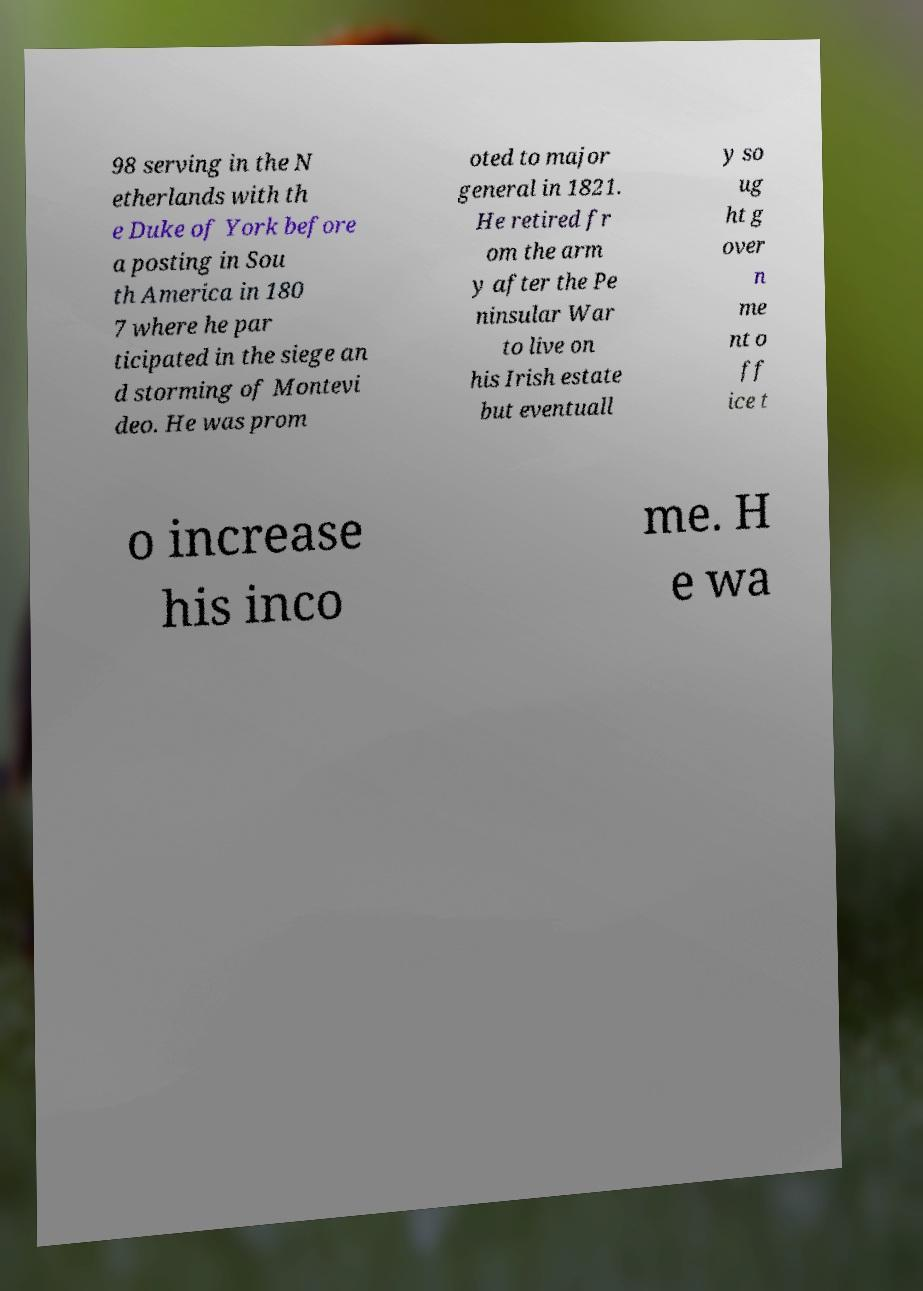There's text embedded in this image that I need extracted. Can you transcribe it verbatim? 98 serving in the N etherlands with th e Duke of York before a posting in Sou th America in 180 7 where he par ticipated in the siege an d storming of Montevi deo. He was prom oted to major general in 1821. He retired fr om the arm y after the Pe ninsular War to live on his Irish estate but eventuall y so ug ht g over n me nt o ff ice t o increase his inco me. H e wa 